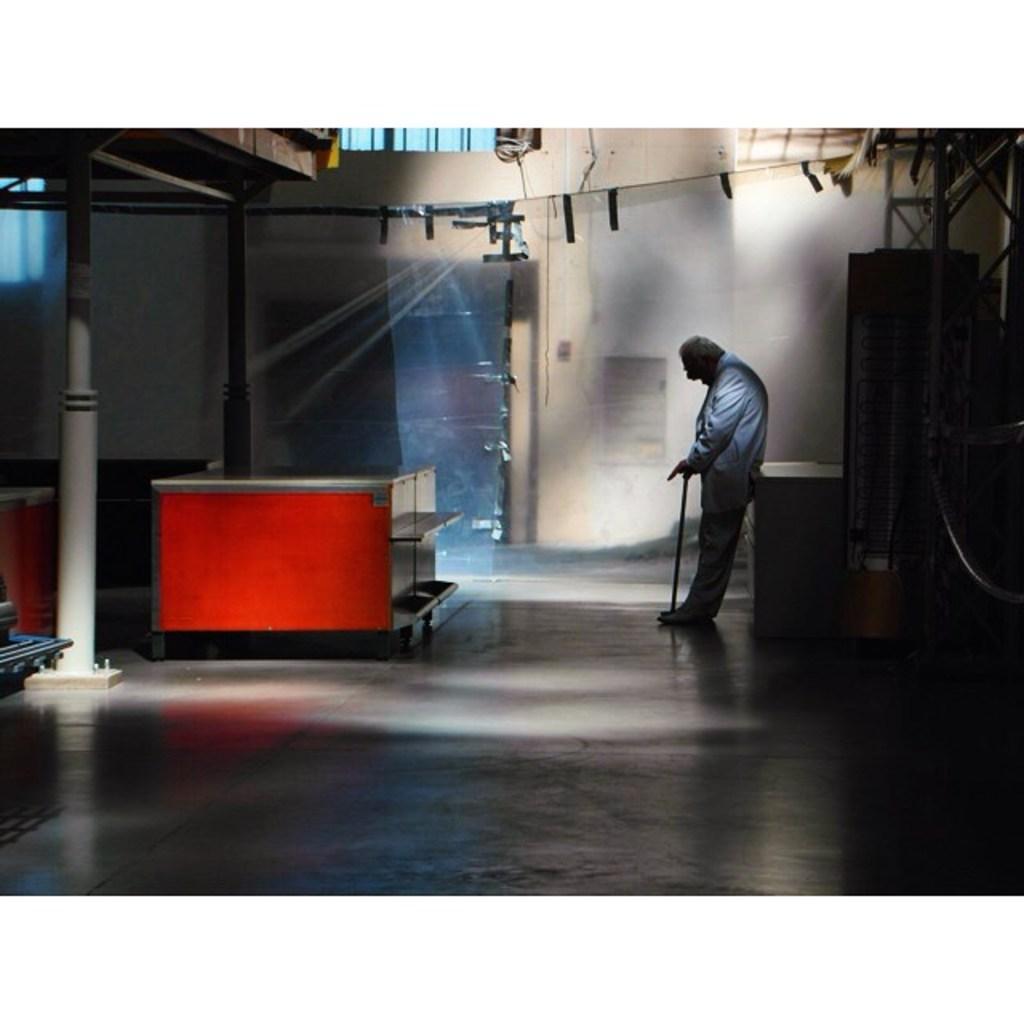In one or two sentences, can you explain what this image depicts? In this image we can see a man standing on the floor holding a stick. We can also see some tables, poles, the metal frame and a wall. 